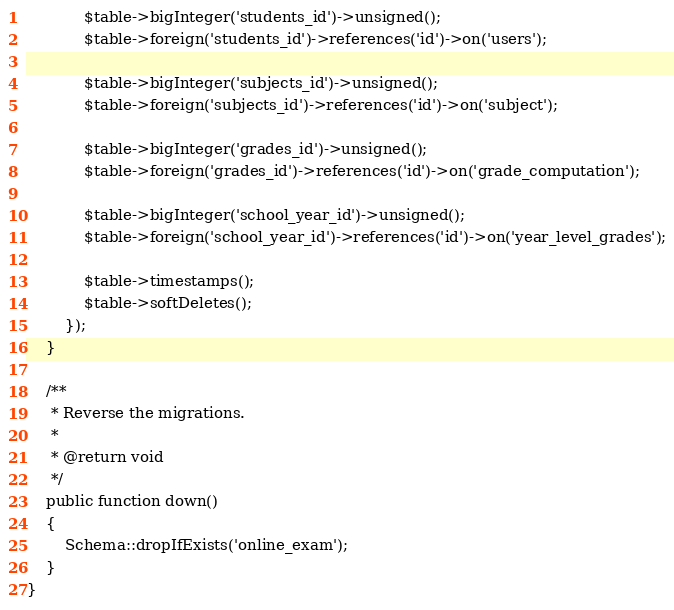<code> <loc_0><loc_0><loc_500><loc_500><_PHP_>            $table->bigInteger('students_id')->unsigned();
            $table->foreign('students_id')->references('id')->on('users');

            $table->bigInteger('subjects_id')->unsigned();
            $table->foreign('subjects_id')->references('id')->on('subject');

            $table->bigInteger('grades_id')->unsigned();
            $table->foreign('grades_id')->references('id')->on('grade_computation');

            $table->bigInteger('school_year_id')->unsigned();
            $table->foreign('school_year_id')->references('id')->on('year_level_grades');

            $table->timestamps();
            $table->softDeletes();
        });
    }

    /**
     * Reverse the migrations.
     *
     * @return void
     */
    public function down()
    {
        Schema::dropIfExists('online_exam');
    }
}
</code> 